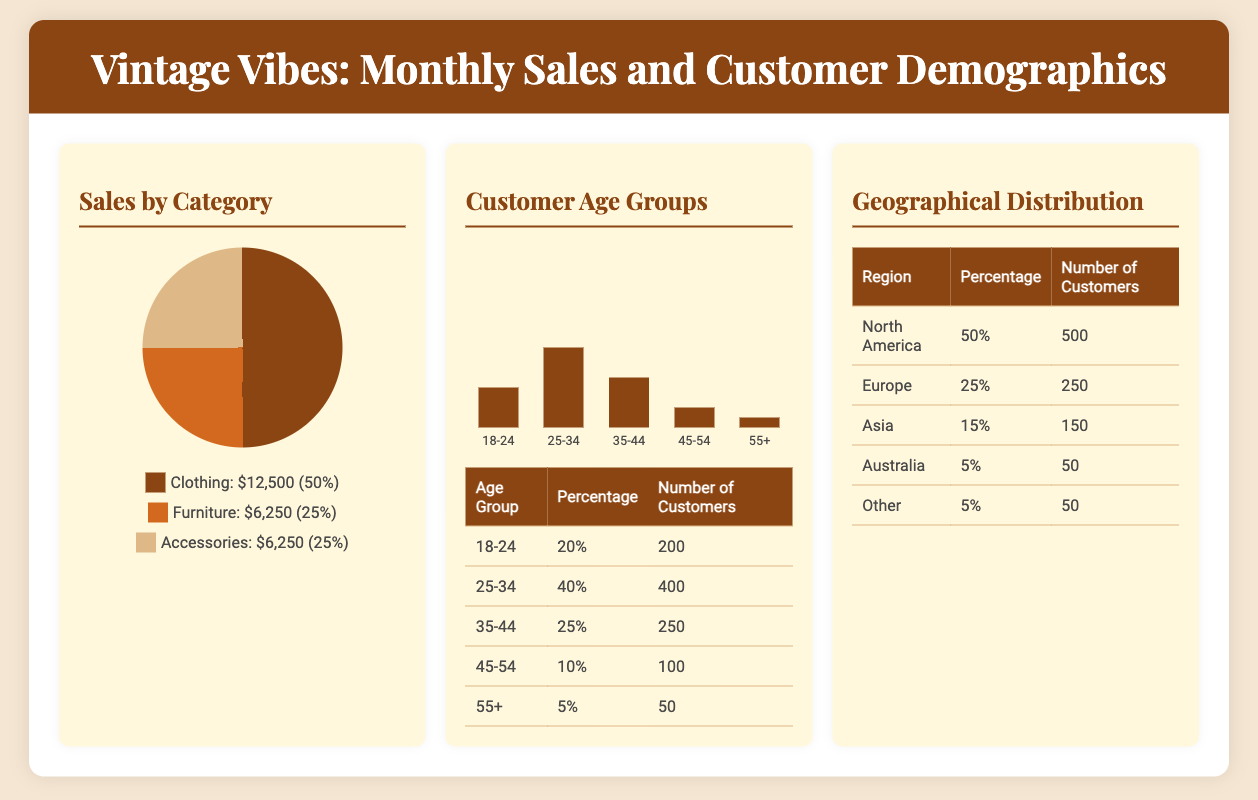what is the percentage of clothing sales? The percentage of clothing sales is provided in the pie chart, which indicates it accounts for 50% of total sales.
Answer: 50% how much revenue did furniture sales generate? The revenue generated from furniture sales is detailed in the pie chart, showing a total of $6,250.
Answer: $6,250 which age group has the highest number of customers? The document lists the customer age groups, and the highest number of customers is in the 25-34 age group with 400 customers.
Answer: 25-34 what is the total number of customers aged 55 and above? To find the total number of customers aged 55 and above, we add the customers from the 55+ age group, which is 50.
Answer: 50 what percentage of sales comes from accessories? The sales percentage for accessories is indicated in the pie chart as 25%.
Answer: 25% which geographical region has the most customers? The geographical distribution table shows that North America has the most customers, accounting for 50%.
Answer: North America what is the total customer count in the 35-44 age group? The document provides numbers for each age group, revealing that the total customer count for the 35-44 age group is 250.
Answer: 250 how many customers are from Europe? The geographical distribution indicates that there are 250 customers from Europe.
Answer: 250 what is the combined revenue from furniture and accessories? The total revenue from furniture ($6,250) and accessories ($6,250) add up to a combined revenue of $12,500.
Answer: $12,500 